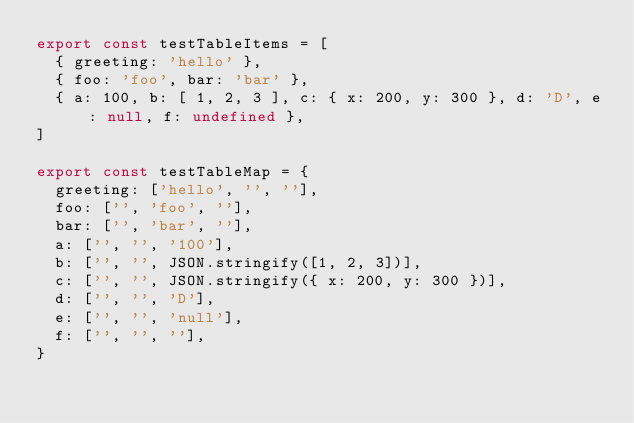Convert code to text. <code><loc_0><loc_0><loc_500><loc_500><_TypeScript_>export const testTableItems = [
  { greeting: 'hello' },
  { foo: 'foo', bar: 'bar' },
  { a: 100, b: [ 1, 2, 3 ], c: { x: 200, y: 300 }, d: 'D', e: null, f: undefined },
]

export const testTableMap = {
  greeting: ['hello', '', ''],
  foo: ['', 'foo', ''],
  bar: ['', 'bar', ''],
  a: ['', '', '100'],
  b: ['', '', JSON.stringify([1, 2, 3])],
  c: ['', '', JSON.stringify({ x: 200, y: 300 })],
  d: ['', '', 'D'],
  e: ['', '', 'null'],
  f: ['', '', ''],
}
</code> 